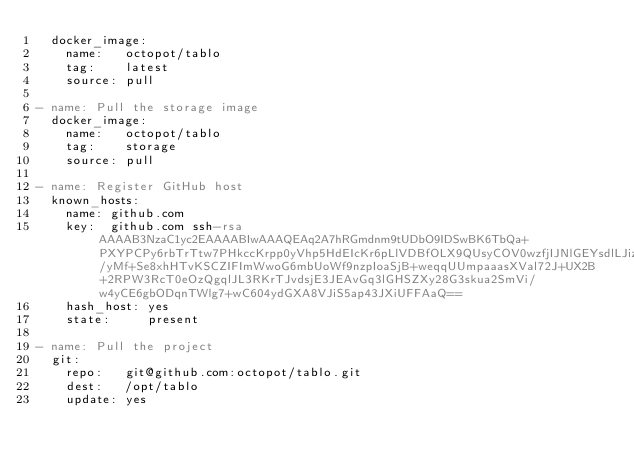<code> <loc_0><loc_0><loc_500><loc_500><_YAML_>  docker_image:
    name:   octopot/tablo
    tag:    latest
    source: pull

- name: Pull the storage image
  docker_image:
    name:   octopot/tablo
    tag:    storage
    source: pull

- name: Register GitHub host
  known_hosts:
    name: github.com
    key:  github.com ssh-rsa AAAAB3NzaC1yc2EAAAABIwAAAQEAq2A7hRGmdnm9tUDbO9IDSwBK6TbQa+PXYPCPy6rbTrTtw7PHkccKrpp0yVhp5HdEIcKr6pLlVDBfOLX9QUsyCOV0wzfjIJNlGEYsdlLJizHhbn2mUjvSAHQqZETYP81eFzLQNnPHt4EVVUh7VfDESU84KezmD5QlWpXLmvU31/yMf+Se8xhHTvKSCZIFImWwoG6mbUoWf9nzpIoaSjB+weqqUUmpaaasXVal72J+UX2B+2RPW3RcT0eOzQgqlJL3RKrTJvdsjE3JEAvGq3lGHSZXy28G3skua2SmVi/w4yCE6gbODqnTWlg7+wC604ydGXA8VJiS5ap43JXiUFFAaQ==
    hash_host: yes
    state:     present

- name: Pull the project
  git:
    repo:   git@github.com:octopot/tablo.git
    dest:   /opt/tablo
    update: yes
</code> 